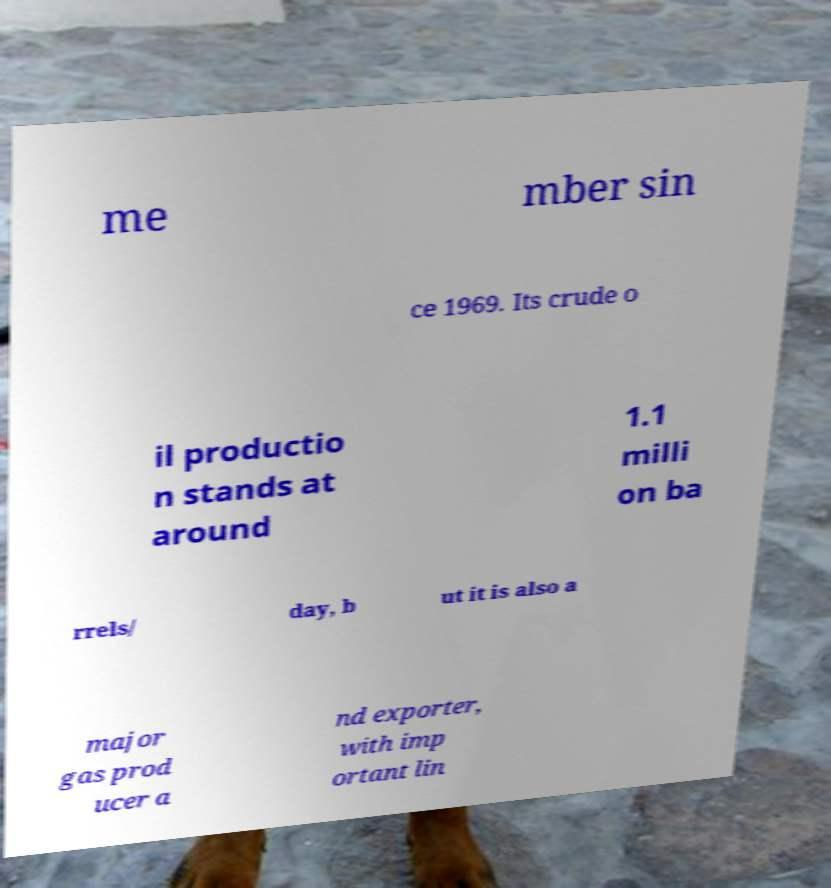There's text embedded in this image that I need extracted. Can you transcribe it verbatim? me mber sin ce 1969. Its crude o il productio n stands at around 1.1 milli on ba rrels/ day, b ut it is also a major gas prod ucer a nd exporter, with imp ortant lin 